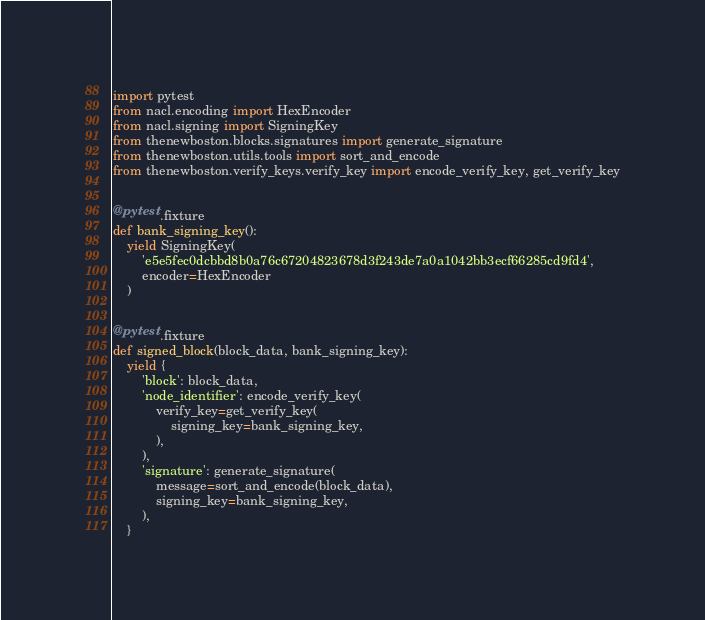<code> <loc_0><loc_0><loc_500><loc_500><_Python_>import pytest
from nacl.encoding import HexEncoder
from nacl.signing import SigningKey
from thenewboston.blocks.signatures import generate_signature
from thenewboston.utils.tools import sort_and_encode
from thenewboston.verify_keys.verify_key import encode_verify_key, get_verify_key


@pytest.fixture
def bank_signing_key():
    yield SigningKey(
        'e5e5fec0dcbbd8b0a76c67204823678d3f243de7a0a1042bb3ecf66285cd9fd4',
        encoder=HexEncoder
    )


@pytest.fixture
def signed_block(block_data, bank_signing_key):
    yield {
        'block': block_data,
        'node_identifier': encode_verify_key(
            verify_key=get_verify_key(
                signing_key=bank_signing_key,
            ),
        ),
        'signature': generate_signature(
            message=sort_and_encode(block_data),
            signing_key=bank_signing_key,
        ),
    }
</code> 